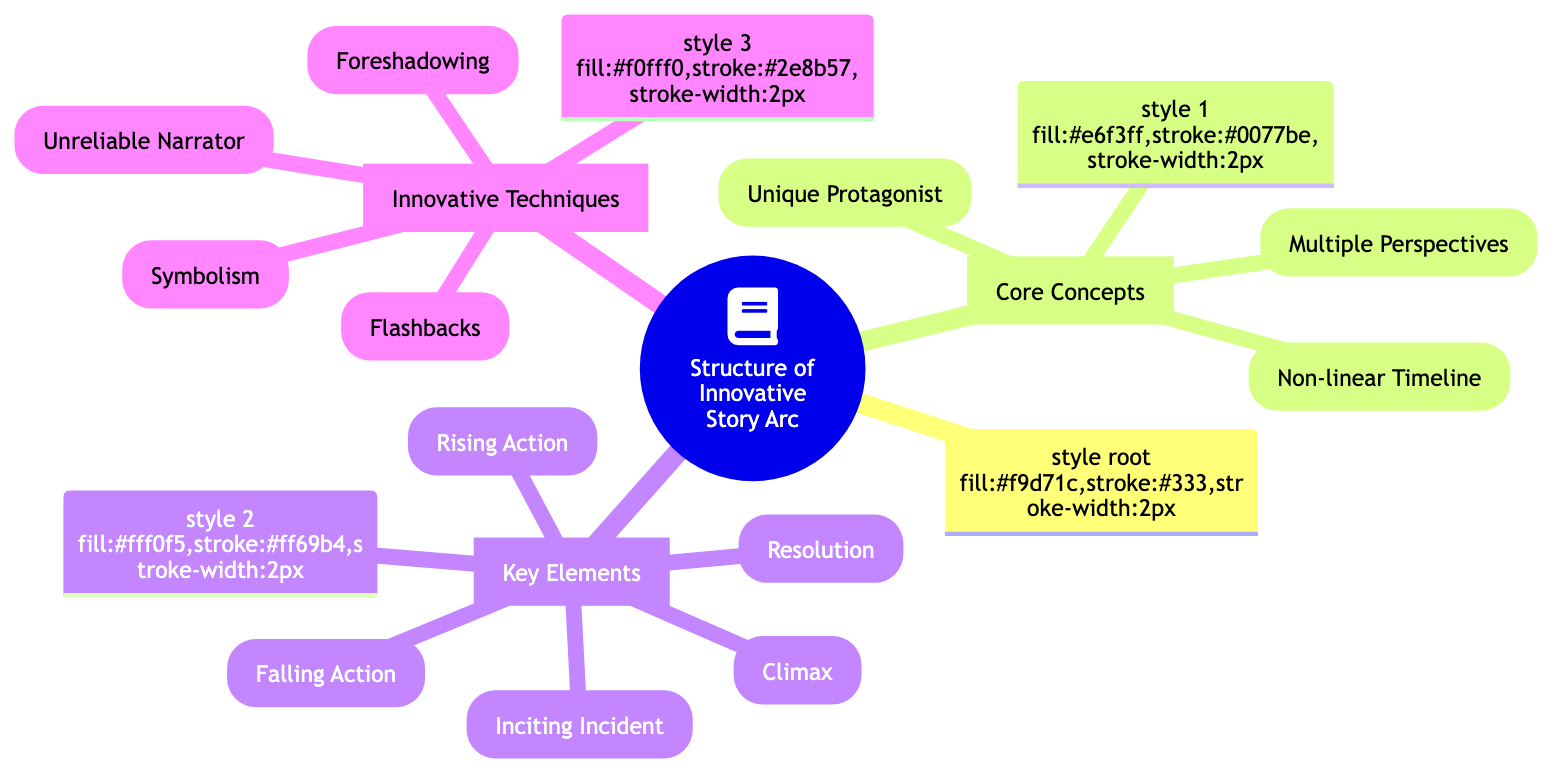What are the three core concepts in the diagram? The diagram lists three core concepts under "Core Concepts": Unique Protagonist, Non-linear Timeline, and Multiple Perspectives.
Answer: Unique Protagonist, Non-linear Timeline, Multiple Perspectives What does "Rising Action" lead to in the story arc? According to the diagram, Rising Action is followed by Climax, indicating that it creates tension leading to the turning point of the story.
Answer: Climax Which narrative technique is used to convey hints about future events? The diagram specifies "Foreshadowing" as the technique that provides hints or clues about future events in the story.
Answer: Foreshadowing How many key elements are identified in the diagram? The diagram outlines five key elements within the "Key Elements" section, which are Inciting Incident, Rising Action, Climax, Falling Action, and Resolution.
Answer: 5 Which innovative technique involves scenes from earlier times? The term "Flashbacks" is listed in the diagram as the technique where scenes are set in a time earlier than the main story.
Answer: Flashbacks What type of protagonist is suggested in the "Core Concepts"? The diagram describes a "Unique Protagonist" as someone with distinct qualities or an unconventional background.
Answer: Unique Protagonist What follows the Climax in the structure? The diagram illustrates that the Falling Action follows the Climax, leading towards resolution after the turning point.
Answer: Falling Action How many innovative techniques are mentioned? In the "Innovative Techniques" section, there are four techniques: Foreshadowing, Flashbacks, Symbolism, and Unreliable Narrator, resulting in a total of four.
Answer: 4 What is an example of a unique protagonist mentioned? The diagram provides the example of Lisbeth Salander from "The Girl with the Dragon Tattoo" to illustrate a unique protagonist.
Answer: Lisbeth Salander 